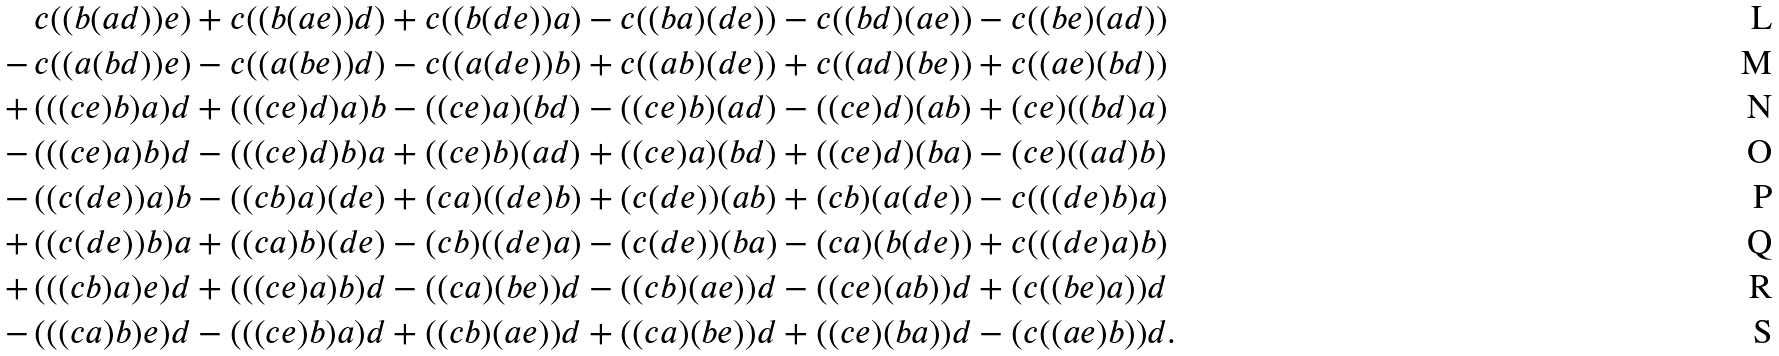<formula> <loc_0><loc_0><loc_500><loc_500>& c ( ( b ( a d ) ) e ) + c ( ( b ( a e ) ) d ) + c ( ( b ( d e ) ) a ) - c ( ( b a ) ( d e ) ) - c ( ( b d ) ( a e ) ) - c ( ( b e ) ( a d ) ) \\ - \, & c ( ( a ( b d ) ) e ) - c ( ( a ( b e ) ) d ) - c ( ( a ( d e ) ) b ) + c ( ( a b ) ( d e ) ) + c ( ( a d ) ( b e ) ) + c ( ( a e ) ( b d ) ) \\ + \, & ( ( ( c e ) b ) a ) d + ( ( ( c e ) d ) a ) b - ( ( c e ) a ) ( b d ) - ( ( c e ) b ) ( a d ) - ( ( c e ) d ) ( a b ) + ( c e ) ( ( b d ) a ) \\ - \, & ( ( ( c e ) a ) b ) d - ( ( ( c e ) d ) b ) a + ( ( c e ) b ) ( a d ) + ( ( c e ) a ) ( b d ) + ( ( c e ) d ) ( b a ) - ( c e ) ( ( a d ) b ) \\ - \, & ( ( c ( d e ) ) a ) b - ( ( c b ) a ) ( d e ) + ( c a ) ( ( d e ) b ) + ( c ( d e ) ) ( a b ) + ( c b ) ( a ( d e ) ) - c ( ( ( d e ) b ) a ) \\ + \, & ( ( c ( d e ) ) b ) a + ( ( c a ) b ) ( d e ) - ( c b ) ( ( d e ) a ) - ( c ( d e ) ) ( b a ) - ( c a ) ( b ( d e ) ) + c ( ( ( d e ) a ) b ) \\ + \, & ( ( ( c b ) a ) e ) d + ( ( ( c e ) a ) b ) d - ( ( c a ) ( b e ) ) d - ( ( c b ) ( a e ) ) d - ( ( c e ) ( a b ) ) d + ( c ( ( b e ) a ) ) d \\ - \, & ( ( ( c a ) b ) e ) d - ( ( ( c e ) b ) a ) d + ( ( c b ) ( a e ) ) d + ( ( c a ) ( b e ) ) d + ( ( c e ) ( b a ) ) d - ( c ( ( a e ) b ) ) d .</formula> 